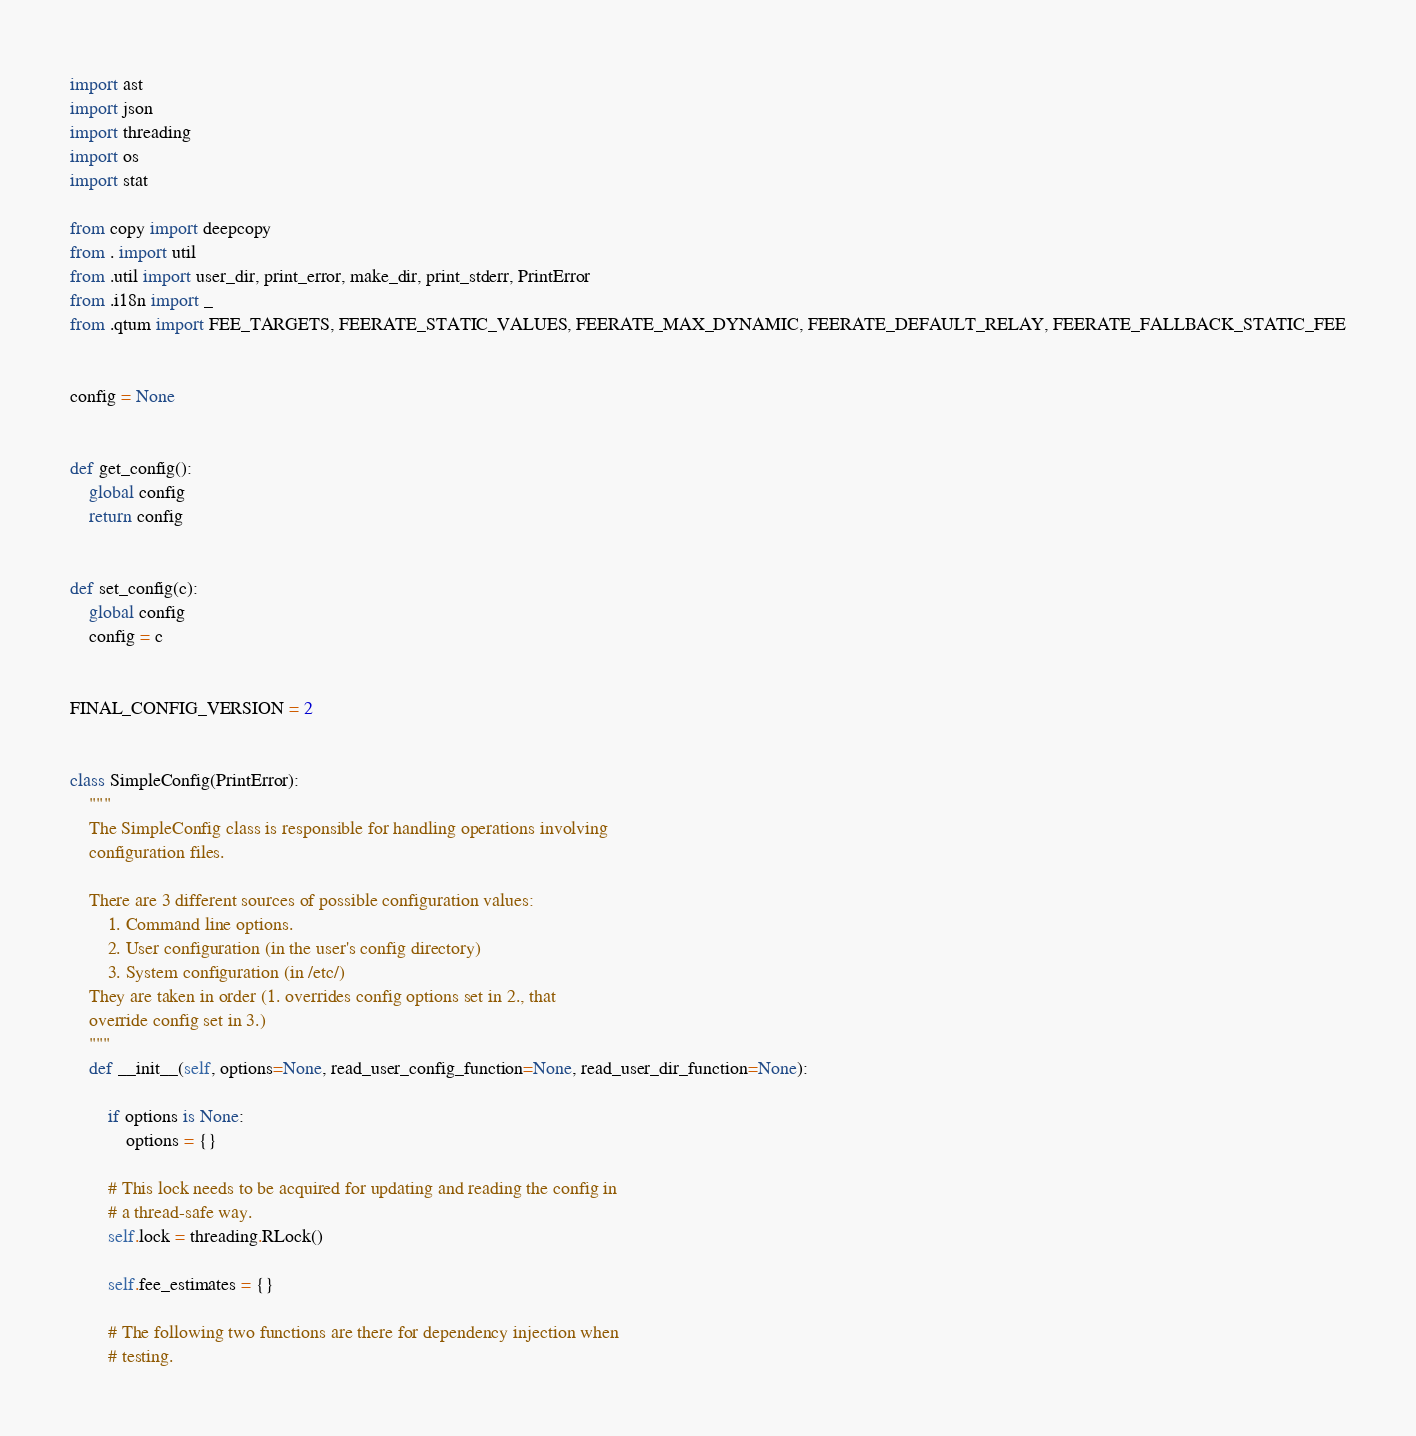Convert code to text. <code><loc_0><loc_0><loc_500><loc_500><_Python_>import ast
import json
import threading
import os
import stat

from copy import deepcopy
from . import util
from .util import user_dir, print_error, make_dir, print_stderr, PrintError
from .i18n import _
from .qtum import FEE_TARGETS, FEERATE_STATIC_VALUES, FEERATE_MAX_DYNAMIC, FEERATE_DEFAULT_RELAY, FEERATE_FALLBACK_STATIC_FEE


config = None


def get_config():
    global config
    return config


def set_config(c):
    global config
    config = c


FINAL_CONFIG_VERSION = 2


class SimpleConfig(PrintError):
    """
    The SimpleConfig class is responsible for handling operations involving
    configuration files.

    There are 3 different sources of possible configuration values:
        1. Command line options.
        2. User configuration (in the user's config directory)
        3. System configuration (in /etc/)
    They are taken in order (1. overrides config options set in 2., that
    override config set in 3.)
    """
    def __init__(self, options=None, read_user_config_function=None, read_user_dir_function=None):

        if options is None:
            options = {}

        # This lock needs to be acquired for updating and reading the config in
        # a thread-safe way.
        self.lock = threading.RLock()

        self.fee_estimates = {}

        # The following two functions are there for dependency injection when
        # testing.</code> 